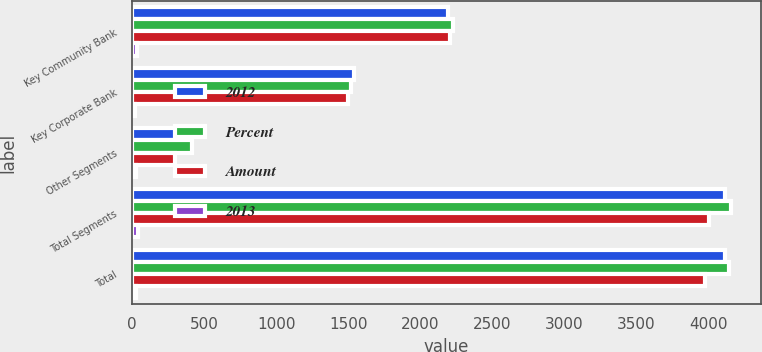Convert chart. <chart><loc_0><loc_0><loc_500><loc_500><stacked_bar_chart><ecel><fcel>Key Community Bank<fcel>Key Corporate Bank<fcel>Other Segments<fcel>Total Segments<fcel>Total<nl><fcel>2012<fcel>2191<fcel>1538<fcel>387<fcel>4116<fcel>4114<nl><fcel>Percent<fcel>2225<fcel>1521<fcel>414<fcel>4160<fcel>4144<nl><fcel>Amount<fcel>2206<fcel>1499<fcel>299<fcel>4004<fcel>3980<nl><fcel>2013<fcel>34<fcel>17<fcel>27<fcel>44<fcel>30<nl></chart> 